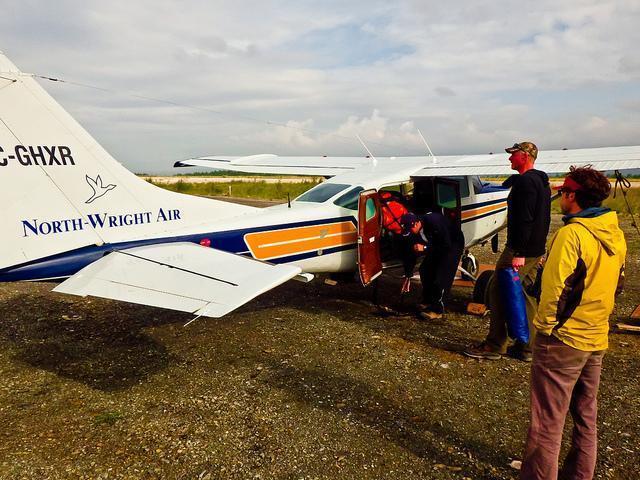How many people can be seen?
Give a very brief answer. 3. How many horses are eating grass?
Give a very brief answer. 0. 